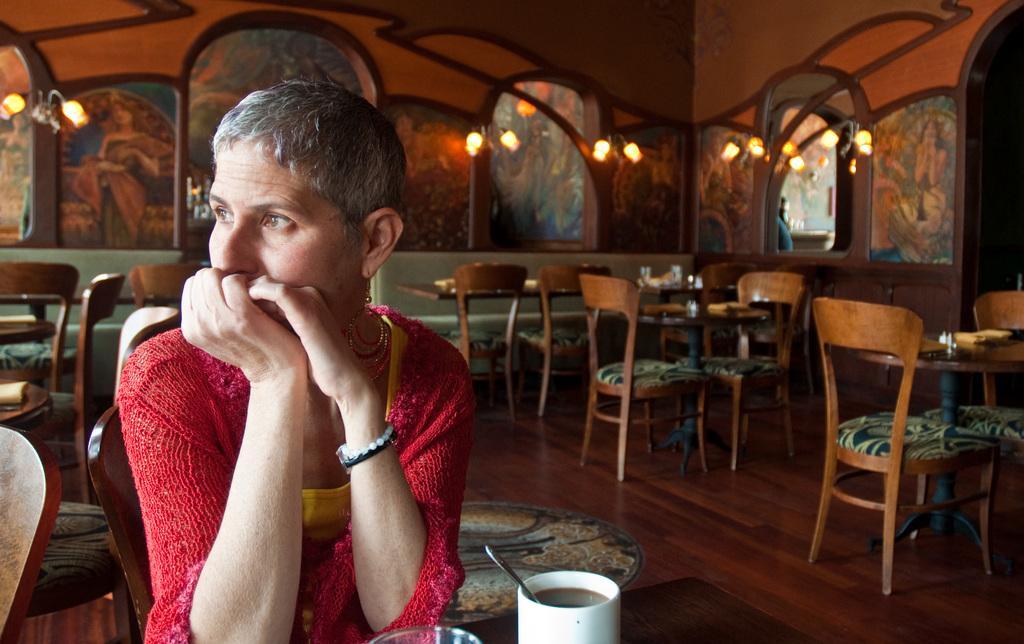Please provide a concise description of this image. This person sitting on the chair. We can see cup,glass on the table and there are chairs. On the background we can see wall,lights. This is floor. 